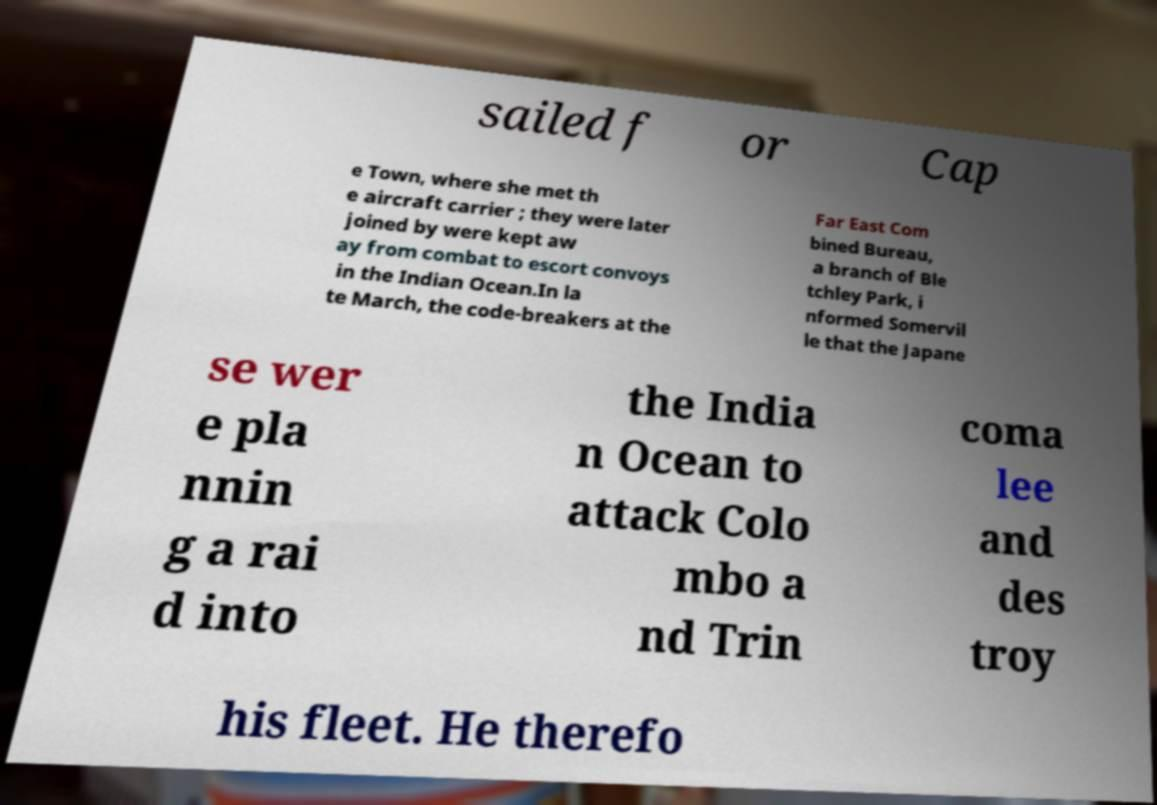Please read and relay the text visible in this image. What does it say? sailed f or Cap e Town, where she met th e aircraft carrier ; they were later joined by were kept aw ay from combat to escort convoys in the Indian Ocean.In la te March, the code-breakers at the Far East Com bined Bureau, a branch of Ble tchley Park, i nformed Somervil le that the Japane se wer e pla nnin g a rai d into the India n Ocean to attack Colo mbo a nd Trin coma lee and des troy his fleet. He therefo 